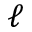<formula> <loc_0><loc_0><loc_500><loc_500>\ell</formula> 